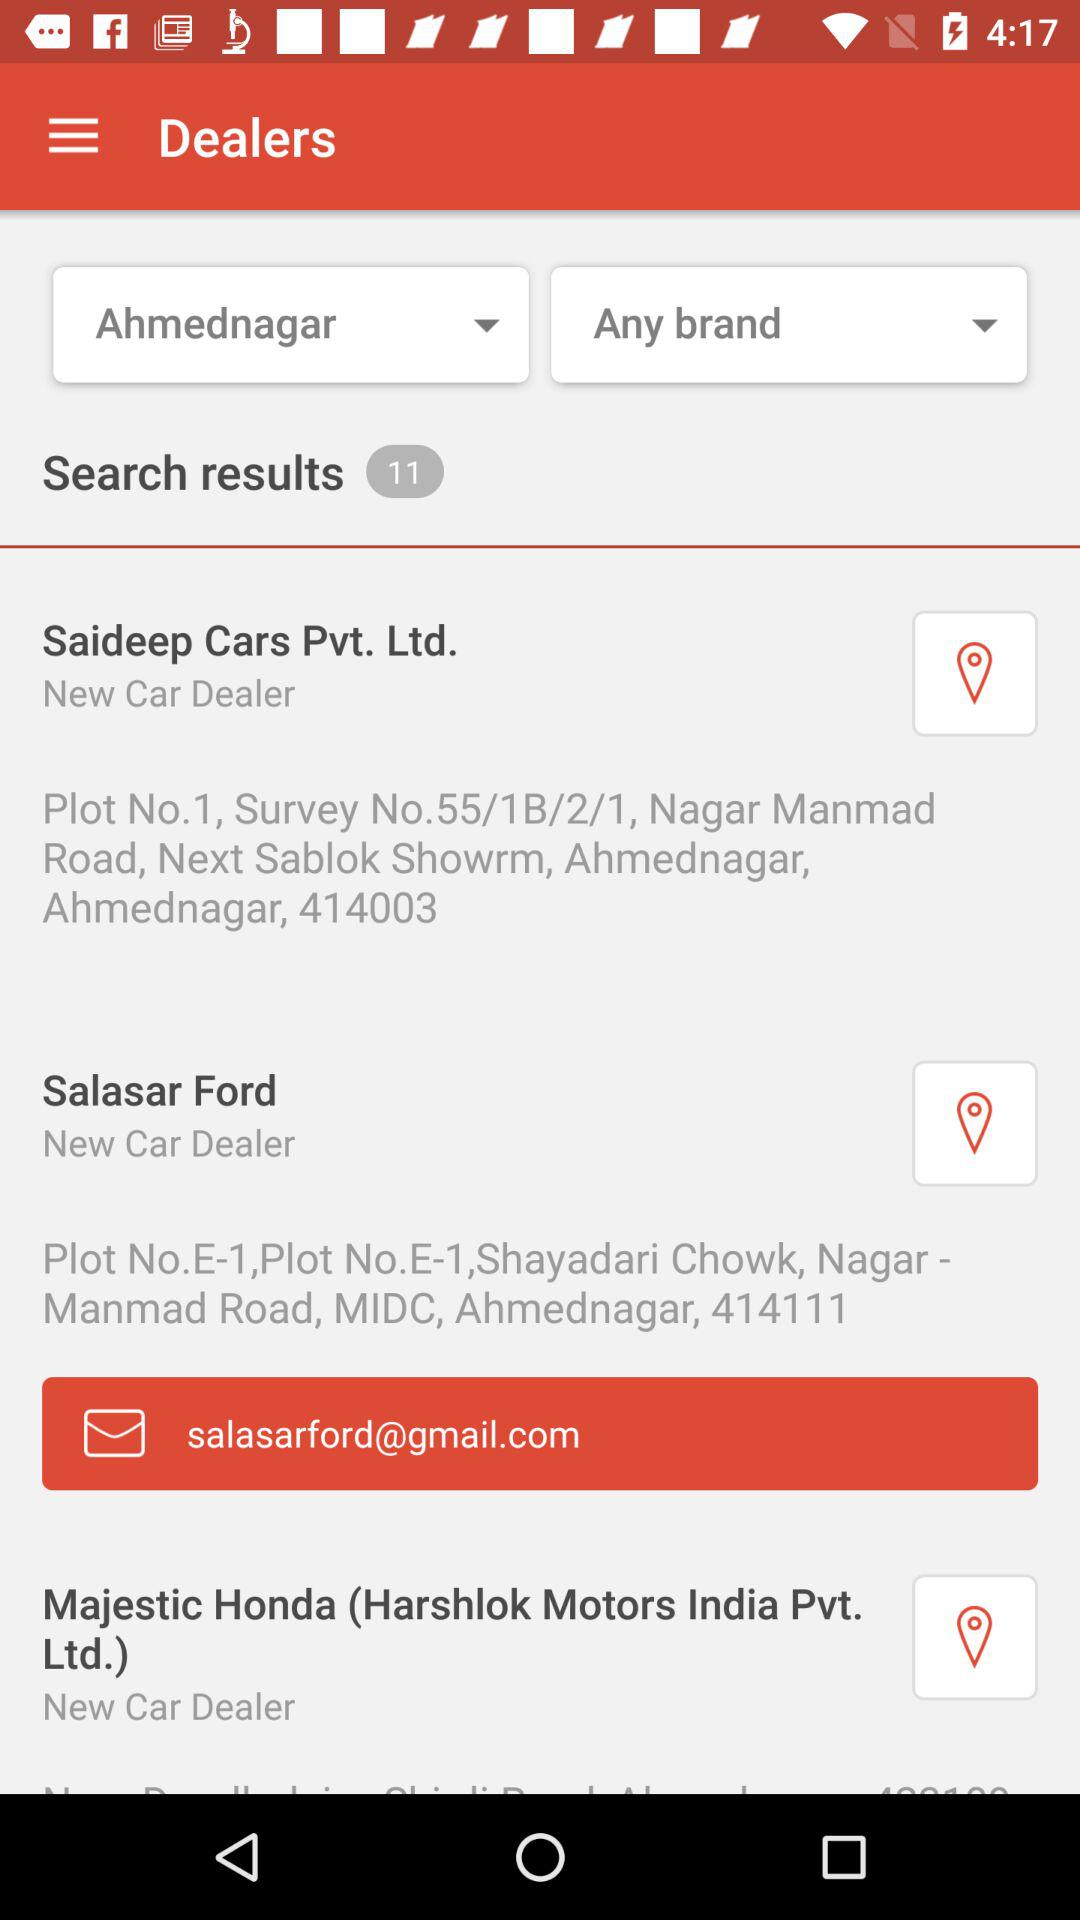What's the address of the "Salasar Ford" dealer? The address of the "Salasar Ford" dealer is Plot No. E-1, Shayadari Chowk, Nagar - Manmad Road, MIDC, Ahmednagar, 414111. 